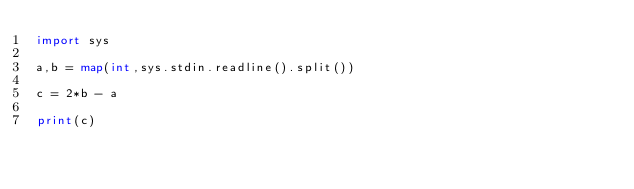<code> <loc_0><loc_0><loc_500><loc_500><_Python_>import sys

a,b = map(int,sys.stdin.readline().split())

c = 2*b - a

print(c)</code> 